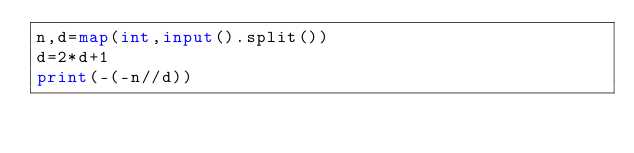Convert code to text. <code><loc_0><loc_0><loc_500><loc_500><_Python_>n,d=map(int,input().split())
d=2*d+1
print(-(-n//d))</code> 